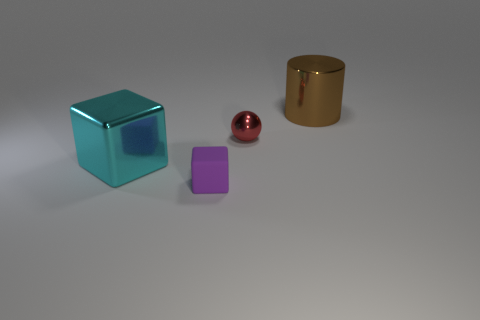There is a cylinder that is the same material as the big cube; what is its size?
Your response must be concise. Large. There is a purple object that is the same size as the ball; what is its material?
Keep it short and to the point. Rubber. There is a big shiny object that is on the right side of the large object that is to the left of the rubber object; what number of big brown objects are in front of it?
Keep it short and to the point. 0. Is the tiny purple object the same shape as the cyan metallic object?
Keep it short and to the point. Yes. Is the material of the big thing that is in front of the brown thing the same as the tiny thing that is behind the tiny purple block?
Provide a succinct answer. Yes. How many things are tiny things to the right of the tiny rubber thing or small things that are behind the purple object?
Provide a succinct answer. 1. Are there any other things that are the same shape as the small red thing?
Give a very brief answer. No. How many blue rubber blocks are there?
Your answer should be compact. 0. Are there any purple cubes of the same size as the cyan block?
Ensure brevity in your answer.  No. Is the material of the brown cylinder the same as the block in front of the large metal cube?
Provide a succinct answer. No. 